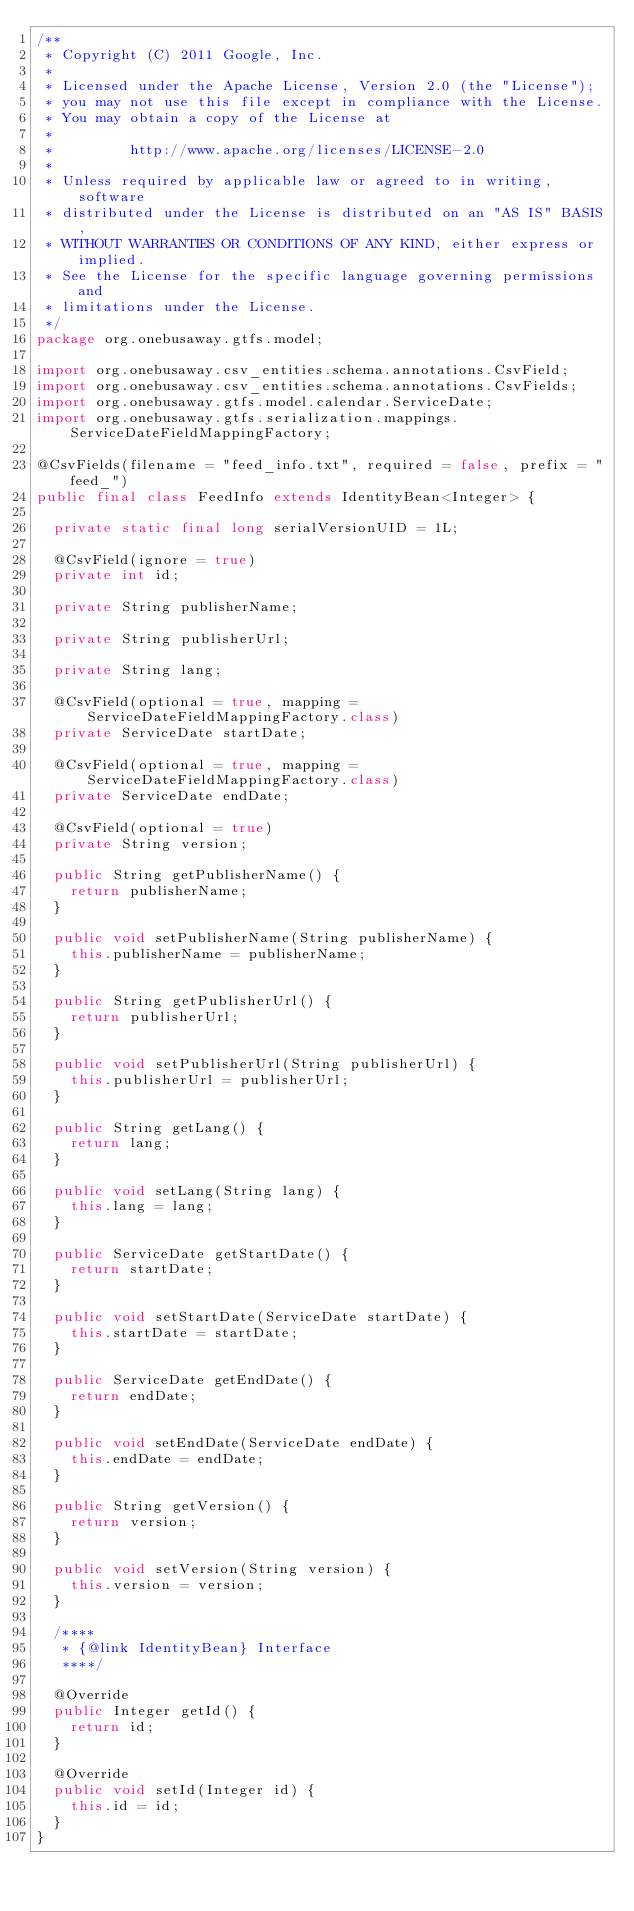<code> <loc_0><loc_0><loc_500><loc_500><_Java_>/**
 * Copyright (C) 2011 Google, Inc.
 *
 * Licensed under the Apache License, Version 2.0 (the "License");
 * you may not use this file except in compliance with the License.
 * You may obtain a copy of the License at
 *
 *         http://www.apache.org/licenses/LICENSE-2.0
 *
 * Unless required by applicable law or agreed to in writing, software
 * distributed under the License is distributed on an "AS IS" BASIS,
 * WITHOUT WARRANTIES OR CONDITIONS OF ANY KIND, either express or implied.
 * See the License for the specific language governing permissions and
 * limitations under the License.
 */
package org.onebusaway.gtfs.model;

import org.onebusaway.csv_entities.schema.annotations.CsvField;
import org.onebusaway.csv_entities.schema.annotations.CsvFields;
import org.onebusaway.gtfs.model.calendar.ServiceDate;
import org.onebusaway.gtfs.serialization.mappings.ServiceDateFieldMappingFactory;

@CsvFields(filename = "feed_info.txt", required = false, prefix = "feed_")
public final class FeedInfo extends IdentityBean<Integer> {

  private static final long serialVersionUID = 1L;

  @CsvField(ignore = true)
  private int id;

  private String publisherName;

  private String publisherUrl;

  private String lang;

  @CsvField(optional = true, mapping = ServiceDateFieldMappingFactory.class)
  private ServiceDate startDate;

  @CsvField(optional = true, mapping = ServiceDateFieldMappingFactory.class)
  private ServiceDate endDate;

  @CsvField(optional = true)
  private String version;

  public String getPublisherName() {
    return publisherName;
  }

  public void setPublisherName(String publisherName) {
    this.publisherName = publisherName;
  }

  public String getPublisherUrl() {
    return publisherUrl;
  }

  public void setPublisherUrl(String publisherUrl) {
    this.publisherUrl = publisherUrl;
  }

  public String getLang() {
    return lang;
  }

  public void setLang(String lang) {
    this.lang = lang;
  }

  public ServiceDate getStartDate() {
    return startDate;
  }

  public void setStartDate(ServiceDate startDate) {
    this.startDate = startDate;
  }

  public ServiceDate getEndDate() {
    return endDate;
  }

  public void setEndDate(ServiceDate endDate) {
    this.endDate = endDate;
  }

  public String getVersion() {
    return version;
  }

  public void setVersion(String version) {
    this.version = version;
  }

  /****
   * {@link IdentityBean} Interface
   ****/

  @Override
  public Integer getId() {
    return id;
  }

  @Override
  public void setId(Integer id) {
    this.id = id;
  }
}
</code> 